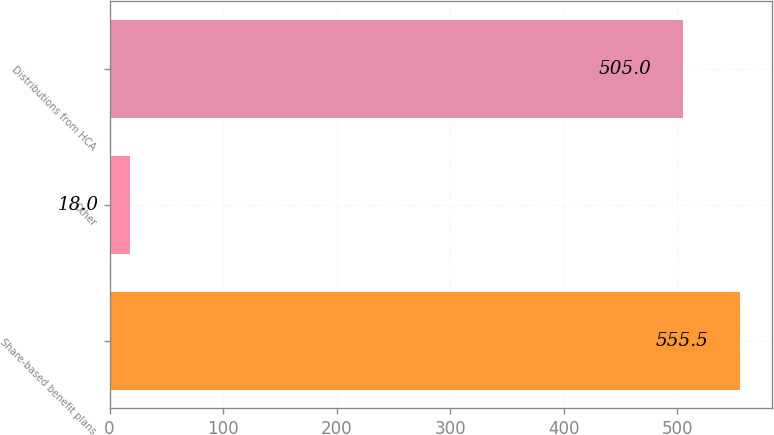<chart> <loc_0><loc_0><loc_500><loc_500><bar_chart><fcel>Share-based benefit plans<fcel>Other<fcel>Distributions from HCA<nl><fcel>555.5<fcel>18<fcel>505<nl></chart> 